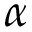Convert formula to latex. <formula><loc_0><loc_0><loc_500><loc_500>\alpha</formula> 